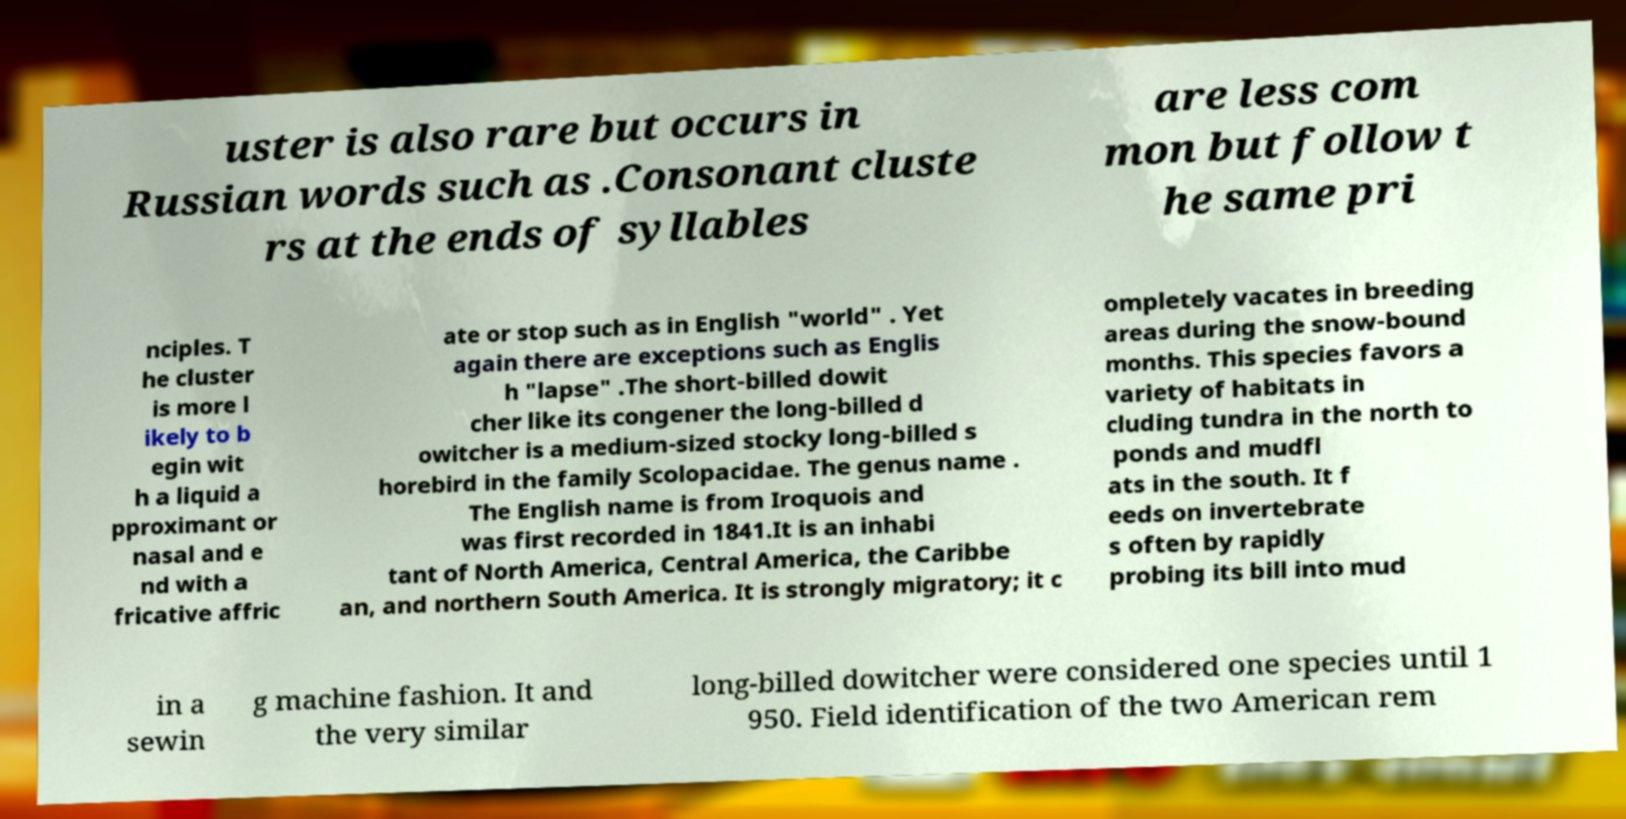Please identify and transcribe the text found in this image. uster is also rare but occurs in Russian words such as .Consonant cluste rs at the ends of syllables are less com mon but follow t he same pri nciples. T he cluster is more l ikely to b egin wit h a liquid a pproximant or nasal and e nd with a fricative affric ate or stop such as in English "world" . Yet again there are exceptions such as Englis h "lapse" .The short-billed dowit cher like its congener the long-billed d owitcher is a medium-sized stocky long-billed s horebird in the family Scolopacidae. The genus name . The English name is from Iroquois and was first recorded in 1841.It is an inhabi tant of North America, Central America, the Caribbe an, and northern South America. It is strongly migratory; it c ompletely vacates in breeding areas during the snow-bound months. This species favors a variety of habitats in cluding tundra in the north to ponds and mudfl ats in the south. It f eeds on invertebrate s often by rapidly probing its bill into mud in a sewin g machine fashion. It and the very similar long-billed dowitcher were considered one species until 1 950. Field identification of the two American rem 